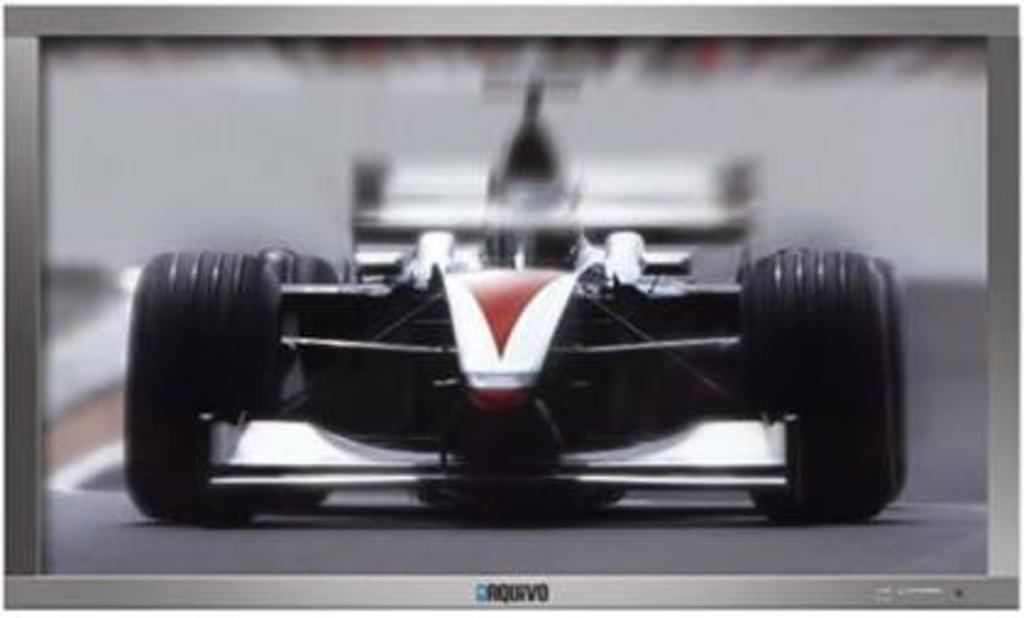What type of screen is present in the image? There is a digital screen in the image. What can be seen on the road in the image? A sports car is visible on the road in the image. What is displayed on the digital screen? The sports car is displayed on the digital screen. How many pears are visible on the digital screen? There are no pears visible on the digital screen; it displays a sports car. Is there a ghost present in the image? There is no ghost present in the image. 